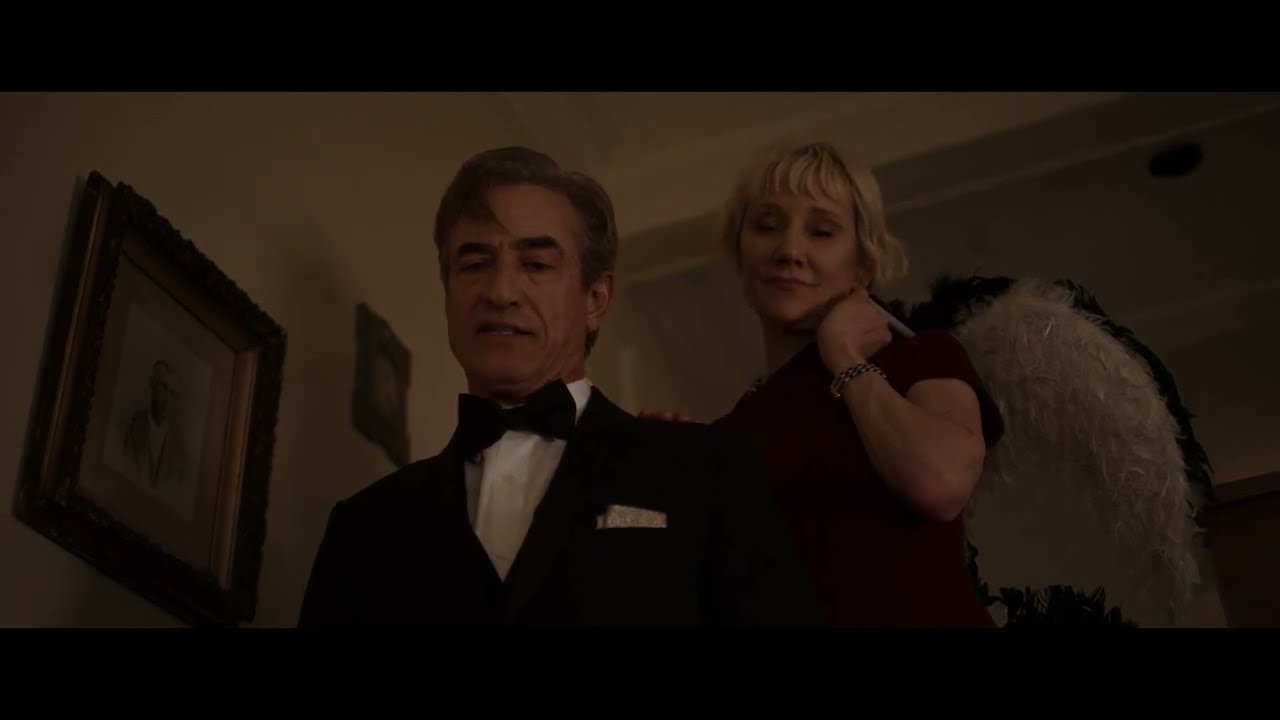What could be the significance of the painting on the wall? The painting on the wall serves as a subtle but important background element in this image. It could indicate the setting is an art gallery, a private collection in a luxurious home, or even an upscale venue. The style of the painting might reflect the taste and sophistication of the individuals, adding layers to their characters and the overall ambiance of the scene. The presence of art suggests a setting where culture and aesthetics are highly valued. Imagine a scenario where these characters are involved in a secret mission. Describe how the image fits into this story. In a thrilling twist, imagine the man in the tuxedo as a seasoned spy, and the elegant woman as his partner in espionage. They have infiltrated a high-society gathering to retrieve a stolen piece of art hidden in plain sight. The painting behind them contains a hidden microfilm with vital information. As they converse, they are subtly exchanging details about their next move. The woman's feather boa, a concealed communication device, signals their accomplice nearby. Every aspect of their appearance and demeanor is a carefully crafted disguise, aiding their covert operation. Start a conversation between these characters, reflecting their roles in the secret mission. {"from": "woman", "value": "Did you notice the painting behind us? It's even more stunning up close."}
{"from": "man", "value": "Indeed. It's remarkable how such beauty can conceal something so critical. The microfilm is hidden within the frame, as we expected."}
{"from": "woman", "value": "I'll distract the guests while you retrieve it. The gala won't resume for another 15 minutes. We have to move quickly."}
{"from": "man", "value": "Understood. Let's hope our cover remains intact."}
{"from": "woman", "value": "Don't worry, darling. We're the best at what we do."}
{"from": "man", "value": "For now, let's stay in character. Remember, elegance and composure."} 